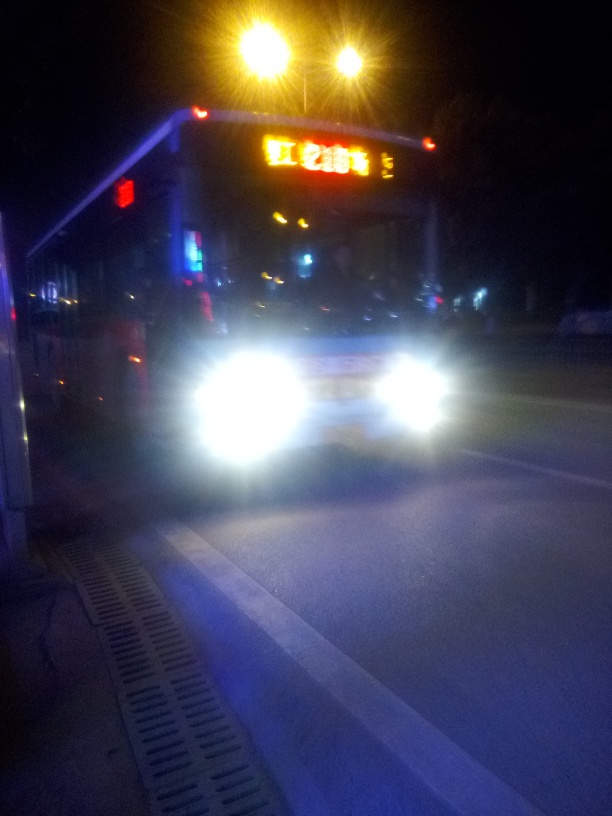Is there anything about this image that suggests it was taken in a specific country or location? Due to the low sharpness and the overexposure of various elements in the image, discerning specific geographic information is challenging. However, the visible text on the illuminated sign appears to be in a script that suggests it could be from a region where non-Latin alphabets are used, such as parts of Asia. Without clearer details, a specific country or location cannot be determined. 